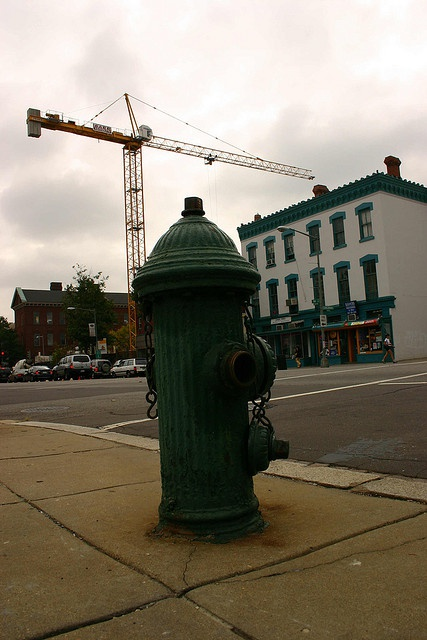Describe the objects in this image and their specific colors. I can see fire hydrant in lightgray, black, gray, and darkgreen tones, car in white, black, gray, darkgray, and maroon tones, car in white, black, gray, and darkgray tones, car in white, black, gray, darkgray, and maroon tones, and car in white, black, gray, and maroon tones in this image. 